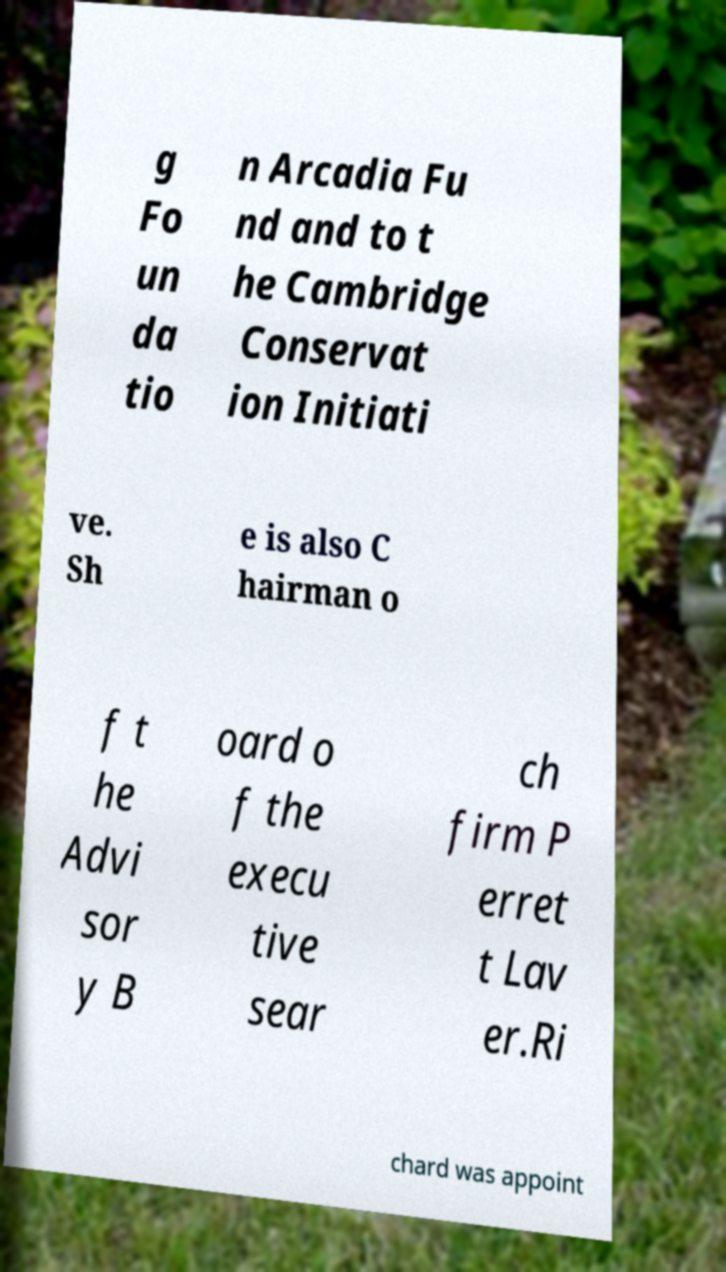Could you extract and type out the text from this image? g Fo un da tio n Arcadia Fu nd and to t he Cambridge Conservat ion Initiati ve. Sh e is also C hairman o f t he Advi sor y B oard o f the execu tive sear ch firm P erret t Lav er.Ri chard was appoint 